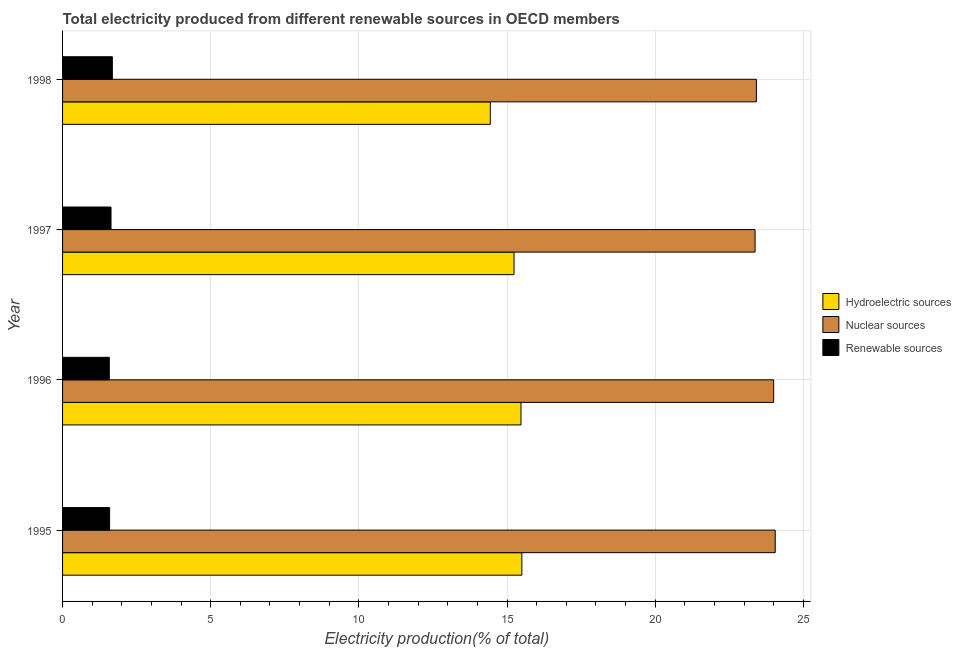How many different coloured bars are there?
Ensure brevity in your answer.  3. How many groups of bars are there?
Ensure brevity in your answer.  4. How many bars are there on the 1st tick from the top?
Make the answer very short. 3. How many bars are there on the 1st tick from the bottom?
Give a very brief answer. 3. In how many cases, is the number of bars for a given year not equal to the number of legend labels?
Ensure brevity in your answer.  0. What is the percentage of electricity produced by nuclear sources in 1995?
Provide a short and direct response. 24.05. Across all years, what is the maximum percentage of electricity produced by nuclear sources?
Offer a terse response. 24.05. Across all years, what is the minimum percentage of electricity produced by hydroelectric sources?
Your response must be concise. 14.44. In which year was the percentage of electricity produced by renewable sources maximum?
Provide a short and direct response. 1998. What is the total percentage of electricity produced by nuclear sources in the graph?
Your answer should be very brief. 94.83. What is the difference between the percentage of electricity produced by nuclear sources in 1996 and that in 1997?
Give a very brief answer. 0.63. What is the difference between the percentage of electricity produced by hydroelectric sources in 1996 and the percentage of electricity produced by nuclear sources in 1995?
Make the answer very short. -8.58. What is the average percentage of electricity produced by hydroelectric sources per year?
Your answer should be compact. 15.16. In the year 1996, what is the difference between the percentage of electricity produced by renewable sources and percentage of electricity produced by nuclear sources?
Provide a short and direct response. -22.42. Is the percentage of electricity produced by renewable sources in 1995 less than that in 1997?
Make the answer very short. Yes. Is the difference between the percentage of electricity produced by nuclear sources in 1995 and 1996 greater than the difference between the percentage of electricity produced by renewable sources in 1995 and 1996?
Ensure brevity in your answer.  Yes. What is the difference between the highest and the second highest percentage of electricity produced by renewable sources?
Give a very brief answer. 0.04. What is the difference between the highest and the lowest percentage of electricity produced by renewable sources?
Offer a terse response. 0.1. What does the 2nd bar from the top in 1995 represents?
Offer a very short reply. Nuclear sources. What does the 3rd bar from the bottom in 1998 represents?
Provide a succinct answer. Renewable sources. How many years are there in the graph?
Provide a succinct answer. 4. Are the values on the major ticks of X-axis written in scientific E-notation?
Make the answer very short. No. Does the graph contain any zero values?
Give a very brief answer. No. How are the legend labels stacked?
Make the answer very short. Vertical. What is the title of the graph?
Give a very brief answer. Total electricity produced from different renewable sources in OECD members. Does "Services" appear as one of the legend labels in the graph?
Your response must be concise. No. What is the Electricity production(% of total) of Hydroelectric sources in 1995?
Keep it short and to the point. 15.5. What is the Electricity production(% of total) of Nuclear sources in 1995?
Give a very brief answer. 24.05. What is the Electricity production(% of total) of Renewable sources in 1995?
Provide a succinct answer. 1.59. What is the Electricity production(% of total) of Hydroelectric sources in 1996?
Offer a terse response. 15.47. What is the Electricity production(% of total) in Nuclear sources in 1996?
Your response must be concise. 24. What is the Electricity production(% of total) in Renewable sources in 1996?
Your answer should be compact. 1.58. What is the Electricity production(% of total) of Hydroelectric sources in 1997?
Offer a very short reply. 15.24. What is the Electricity production(% of total) in Nuclear sources in 1997?
Your response must be concise. 23.37. What is the Electricity production(% of total) in Renewable sources in 1997?
Keep it short and to the point. 1.64. What is the Electricity production(% of total) in Hydroelectric sources in 1998?
Offer a terse response. 14.44. What is the Electricity production(% of total) of Nuclear sources in 1998?
Provide a succinct answer. 23.41. What is the Electricity production(% of total) in Renewable sources in 1998?
Give a very brief answer. 1.68. Across all years, what is the maximum Electricity production(% of total) of Hydroelectric sources?
Your response must be concise. 15.5. Across all years, what is the maximum Electricity production(% of total) in Nuclear sources?
Provide a succinct answer. 24.05. Across all years, what is the maximum Electricity production(% of total) in Renewable sources?
Offer a very short reply. 1.68. Across all years, what is the minimum Electricity production(% of total) in Hydroelectric sources?
Offer a terse response. 14.44. Across all years, what is the minimum Electricity production(% of total) in Nuclear sources?
Provide a succinct answer. 23.37. Across all years, what is the minimum Electricity production(% of total) of Renewable sources?
Provide a succinct answer. 1.58. What is the total Electricity production(% of total) in Hydroelectric sources in the graph?
Keep it short and to the point. 60.64. What is the total Electricity production(% of total) in Nuclear sources in the graph?
Your answer should be very brief. 94.83. What is the total Electricity production(% of total) of Renewable sources in the graph?
Offer a terse response. 6.48. What is the difference between the Electricity production(% of total) in Hydroelectric sources in 1995 and that in 1996?
Keep it short and to the point. 0.03. What is the difference between the Electricity production(% of total) of Nuclear sources in 1995 and that in 1996?
Ensure brevity in your answer.  0.05. What is the difference between the Electricity production(% of total) of Renewable sources in 1995 and that in 1996?
Offer a terse response. 0.01. What is the difference between the Electricity production(% of total) of Hydroelectric sources in 1995 and that in 1997?
Make the answer very short. 0.26. What is the difference between the Electricity production(% of total) in Nuclear sources in 1995 and that in 1997?
Your answer should be compact. 0.68. What is the difference between the Electricity production(% of total) of Renewable sources in 1995 and that in 1997?
Ensure brevity in your answer.  -0.05. What is the difference between the Electricity production(% of total) in Hydroelectric sources in 1995 and that in 1998?
Make the answer very short. 1.06. What is the difference between the Electricity production(% of total) of Nuclear sources in 1995 and that in 1998?
Offer a terse response. 0.64. What is the difference between the Electricity production(% of total) of Renewable sources in 1995 and that in 1998?
Offer a very short reply. -0.09. What is the difference between the Electricity production(% of total) in Hydroelectric sources in 1996 and that in 1997?
Make the answer very short. 0.24. What is the difference between the Electricity production(% of total) in Nuclear sources in 1996 and that in 1997?
Your answer should be very brief. 0.63. What is the difference between the Electricity production(% of total) of Renewable sources in 1996 and that in 1997?
Make the answer very short. -0.06. What is the difference between the Electricity production(% of total) of Hydroelectric sources in 1996 and that in 1998?
Keep it short and to the point. 1.04. What is the difference between the Electricity production(% of total) of Nuclear sources in 1996 and that in 1998?
Keep it short and to the point. 0.58. What is the difference between the Electricity production(% of total) in Renewable sources in 1996 and that in 1998?
Give a very brief answer. -0.1. What is the difference between the Electricity production(% of total) of Hydroelectric sources in 1997 and that in 1998?
Provide a succinct answer. 0.8. What is the difference between the Electricity production(% of total) in Nuclear sources in 1997 and that in 1998?
Give a very brief answer. -0.04. What is the difference between the Electricity production(% of total) of Renewable sources in 1997 and that in 1998?
Give a very brief answer. -0.04. What is the difference between the Electricity production(% of total) in Hydroelectric sources in 1995 and the Electricity production(% of total) in Nuclear sources in 1996?
Keep it short and to the point. -8.5. What is the difference between the Electricity production(% of total) of Hydroelectric sources in 1995 and the Electricity production(% of total) of Renewable sources in 1996?
Offer a very short reply. 13.92. What is the difference between the Electricity production(% of total) in Nuclear sources in 1995 and the Electricity production(% of total) in Renewable sources in 1996?
Your answer should be very brief. 22.47. What is the difference between the Electricity production(% of total) of Hydroelectric sources in 1995 and the Electricity production(% of total) of Nuclear sources in 1997?
Offer a very short reply. -7.87. What is the difference between the Electricity production(% of total) in Hydroelectric sources in 1995 and the Electricity production(% of total) in Renewable sources in 1997?
Offer a very short reply. 13.86. What is the difference between the Electricity production(% of total) in Nuclear sources in 1995 and the Electricity production(% of total) in Renewable sources in 1997?
Provide a short and direct response. 22.42. What is the difference between the Electricity production(% of total) in Hydroelectric sources in 1995 and the Electricity production(% of total) in Nuclear sources in 1998?
Provide a short and direct response. -7.91. What is the difference between the Electricity production(% of total) in Hydroelectric sources in 1995 and the Electricity production(% of total) in Renewable sources in 1998?
Offer a terse response. 13.82. What is the difference between the Electricity production(% of total) of Nuclear sources in 1995 and the Electricity production(% of total) of Renewable sources in 1998?
Your answer should be compact. 22.37. What is the difference between the Electricity production(% of total) in Hydroelectric sources in 1996 and the Electricity production(% of total) in Nuclear sources in 1997?
Offer a terse response. -7.9. What is the difference between the Electricity production(% of total) of Hydroelectric sources in 1996 and the Electricity production(% of total) of Renewable sources in 1997?
Your answer should be very brief. 13.84. What is the difference between the Electricity production(% of total) of Nuclear sources in 1996 and the Electricity production(% of total) of Renewable sources in 1997?
Your response must be concise. 22.36. What is the difference between the Electricity production(% of total) of Hydroelectric sources in 1996 and the Electricity production(% of total) of Nuclear sources in 1998?
Provide a short and direct response. -7.94. What is the difference between the Electricity production(% of total) of Hydroelectric sources in 1996 and the Electricity production(% of total) of Renewable sources in 1998?
Provide a short and direct response. 13.79. What is the difference between the Electricity production(% of total) in Nuclear sources in 1996 and the Electricity production(% of total) in Renewable sources in 1998?
Make the answer very short. 22.32. What is the difference between the Electricity production(% of total) in Hydroelectric sources in 1997 and the Electricity production(% of total) in Nuclear sources in 1998?
Your answer should be very brief. -8.18. What is the difference between the Electricity production(% of total) in Hydroelectric sources in 1997 and the Electricity production(% of total) in Renewable sources in 1998?
Offer a very short reply. 13.56. What is the difference between the Electricity production(% of total) in Nuclear sources in 1997 and the Electricity production(% of total) in Renewable sources in 1998?
Offer a terse response. 21.69. What is the average Electricity production(% of total) of Hydroelectric sources per year?
Give a very brief answer. 15.16. What is the average Electricity production(% of total) of Nuclear sources per year?
Your answer should be compact. 23.71. What is the average Electricity production(% of total) in Renewable sources per year?
Provide a short and direct response. 1.62. In the year 1995, what is the difference between the Electricity production(% of total) in Hydroelectric sources and Electricity production(% of total) in Nuclear sources?
Keep it short and to the point. -8.55. In the year 1995, what is the difference between the Electricity production(% of total) of Hydroelectric sources and Electricity production(% of total) of Renewable sources?
Ensure brevity in your answer.  13.91. In the year 1995, what is the difference between the Electricity production(% of total) in Nuclear sources and Electricity production(% of total) in Renewable sources?
Your answer should be compact. 22.46. In the year 1996, what is the difference between the Electricity production(% of total) of Hydroelectric sources and Electricity production(% of total) of Nuclear sources?
Your response must be concise. -8.53. In the year 1996, what is the difference between the Electricity production(% of total) of Hydroelectric sources and Electricity production(% of total) of Renewable sources?
Your response must be concise. 13.89. In the year 1996, what is the difference between the Electricity production(% of total) of Nuclear sources and Electricity production(% of total) of Renewable sources?
Offer a terse response. 22.42. In the year 1997, what is the difference between the Electricity production(% of total) in Hydroelectric sources and Electricity production(% of total) in Nuclear sources?
Make the answer very short. -8.13. In the year 1997, what is the difference between the Electricity production(% of total) of Hydroelectric sources and Electricity production(% of total) of Renewable sources?
Your response must be concise. 13.6. In the year 1997, what is the difference between the Electricity production(% of total) in Nuclear sources and Electricity production(% of total) in Renewable sources?
Offer a very short reply. 21.74. In the year 1998, what is the difference between the Electricity production(% of total) of Hydroelectric sources and Electricity production(% of total) of Nuclear sources?
Make the answer very short. -8.98. In the year 1998, what is the difference between the Electricity production(% of total) of Hydroelectric sources and Electricity production(% of total) of Renewable sources?
Offer a terse response. 12.76. In the year 1998, what is the difference between the Electricity production(% of total) in Nuclear sources and Electricity production(% of total) in Renewable sources?
Ensure brevity in your answer.  21.73. What is the ratio of the Electricity production(% of total) of Renewable sources in 1995 to that in 1996?
Ensure brevity in your answer.  1.01. What is the ratio of the Electricity production(% of total) in Hydroelectric sources in 1995 to that in 1997?
Your response must be concise. 1.02. What is the ratio of the Electricity production(% of total) in Nuclear sources in 1995 to that in 1997?
Offer a terse response. 1.03. What is the ratio of the Electricity production(% of total) in Renewable sources in 1995 to that in 1997?
Your answer should be very brief. 0.97. What is the ratio of the Electricity production(% of total) in Hydroelectric sources in 1995 to that in 1998?
Make the answer very short. 1.07. What is the ratio of the Electricity production(% of total) in Nuclear sources in 1995 to that in 1998?
Your answer should be compact. 1.03. What is the ratio of the Electricity production(% of total) of Renewable sources in 1995 to that in 1998?
Make the answer very short. 0.95. What is the ratio of the Electricity production(% of total) of Hydroelectric sources in 1996 to that in 1997?
Offer a terse response. 1.02. What is the ratio of the Electricity production(% of total) of Nuclear sources in 1996 to that in 1997?
Your response must be concise. 1.03. What is the ratio of the Electricity production(% of total) in Renewable sources in 1996 to that in 1997?
Give a very brief answer. 0.96. What is the ratio of the Electricity production(% of total) in Hydroelectric sources in 1996 to that in 1998?
Your answer should be very brief. 1.07. What is the ratio of the Electricity production(% of total) of Nuclear sources in 1996 to that in 1998?
Your answer should be very brief. 1.02. What is the ratio of the Electricity production(% of total) of Renewable sources in 1996 to that in 1998?
Provide a succinct answer. 0.94. What is the ratio of the Electricity production(% of total) in Hydroelectric sources in 1997 to that in 1998?
Provide a succinct answer. 1.06. What is the ratio of the Electricity production(% of total) in Renewable sources in 1997 to that in 1998?
Provide a short and direct response. 0.97. What is the difference between the highest and the second highest Electricity production(% of total) in Hydroelectric sources?
Your response must be concise. 0.03. What is the difference between the highest and the second highest Electricity production(% of total) of Nuclear sources?
Your response must be concise. 0.05. What is the difference between the highest and the second highest Electricity production(% of total) of Renewable sources?
Your answer should be compact. 0.04. What is the difference between the highest and the lowest Electricity production(% of total) of Hydroelectric sources?
Give a very brief answer. 1.06. What is the difference between the highest and the lowest Electricity production(% of total) in Nuclear sources?
Your answer should be very brief. 0.68. What is the difference between the highest and the lowest Electricity production(% of total) of Renewable sources?
Your answer should be very brief. 0.1. 